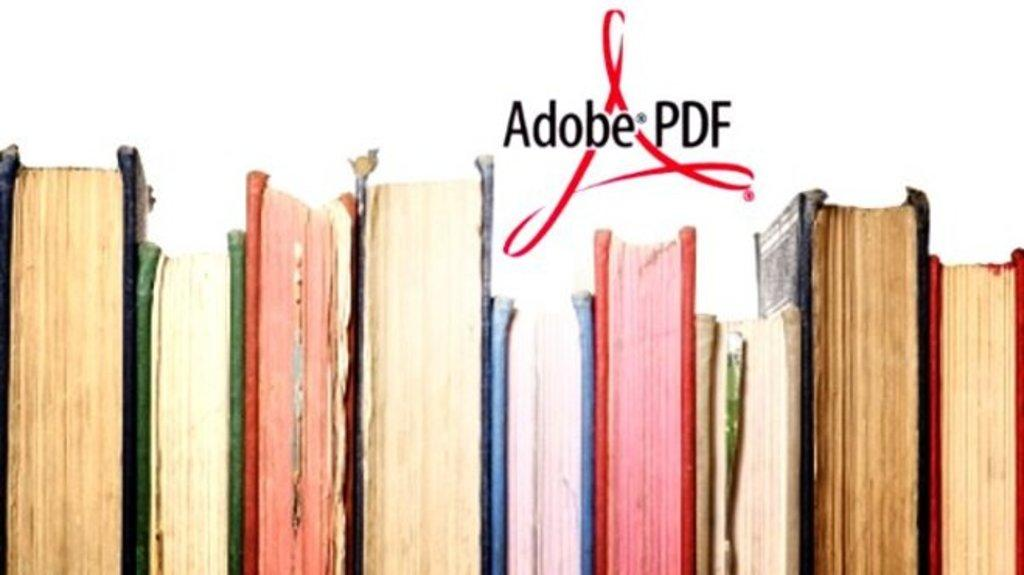<image>
Share a concise interpretation of the image provided. An advertisement for Adobe PDF that includes the logo and a lineup of old books 